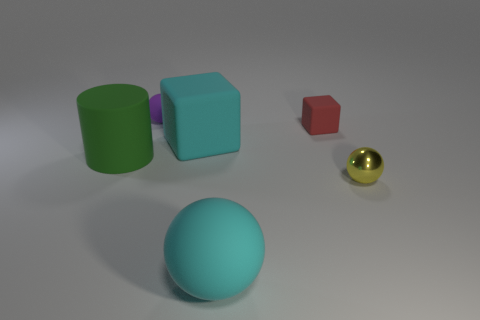Is the big cyan object that is behind the large sphere made of the same material as the thing that is left of the purple rubber object?
Offer a very short reply. Yes. What shape is the tiny thing to the right of the red cube?
Offer a terse response. Sphere. Are there fewer large green shiny spheres than red rubber cubes?
Ensure brevity in your answer.  Yes. There is a object that is on the left side of the small matte thing that is on the left side of the tiny red rubber thing; is there a ball behind it?
Offer a very short reply. Yes. What number of matte objects are either small purple spheres or tiny yellow spheres?
Make the answer very short. 1. Is the color of the tiny block the same as the tiny shiny thing?
Give a very brief answer. No. How many cyan blocks are right of the big green rubber object?
Ensure brevity in your answer.  1. How many things are in front of the cylinder and left of the tiny yellow shiny thing?
Ensure brevity in your answer.  1. There is a large green object that is made of the same material as the tiny purple thing; what shape is it?
Provide a short and direct response. Cylinder. Does the ball that is in front of the tiny yellow shiny object have the same size as the cyan matte object behind the cylinder?
Offer a terse response. Yes. 